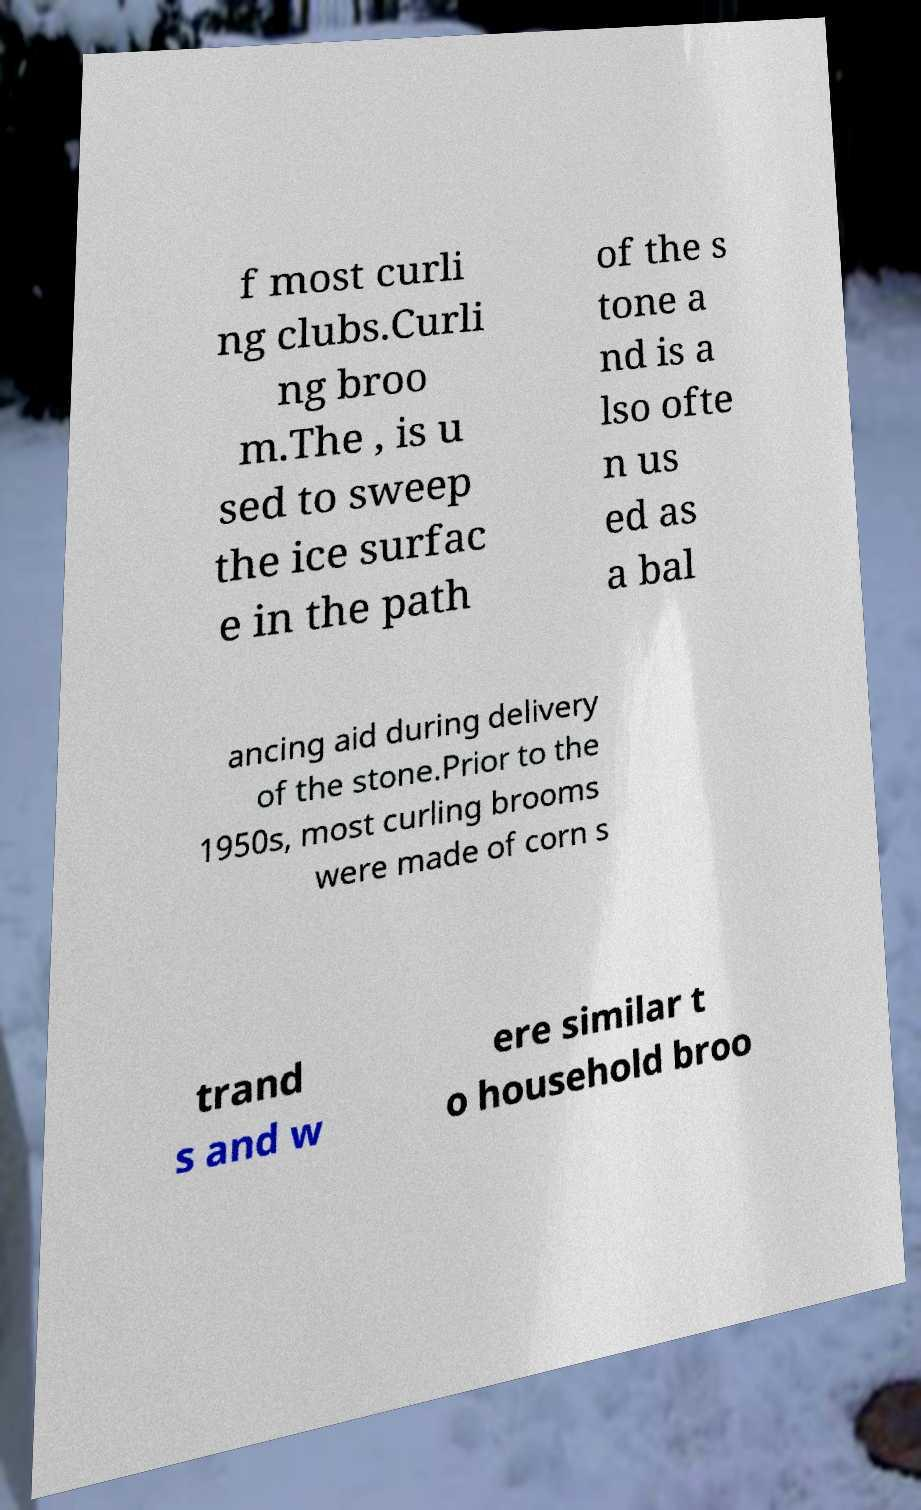Can you accurately transcribe the text from the provided image for me? f most curli ng clubs.Curli ng broo m.The , is u sed to sweep the ice surfac e in the path of the s tone a nd is a lso ofte n us ed as a bal ancing aid during delivery of the stone.Prior to the 1950s, most curling brooms were made of corn s trand s and w ere similar t o household broo 